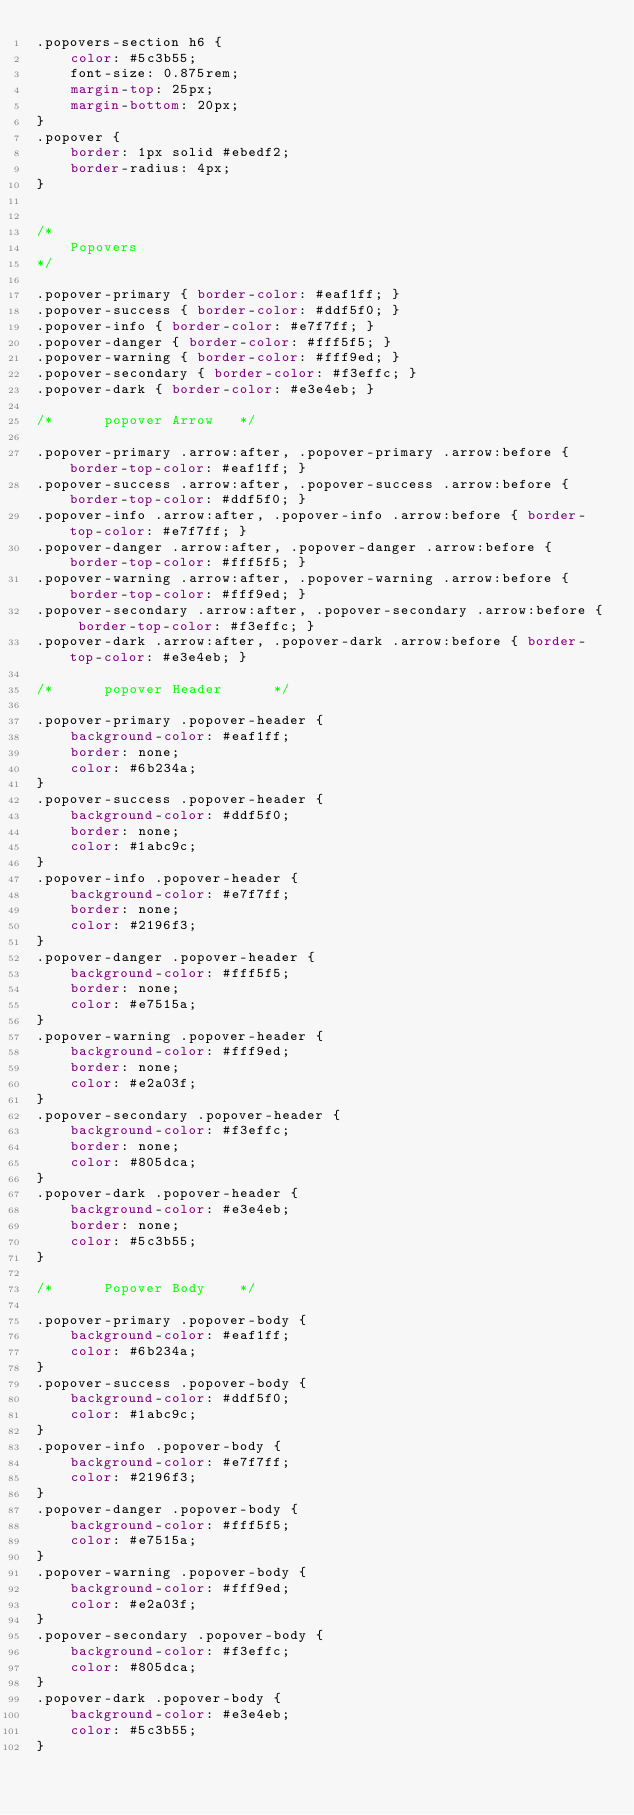Convert code to text. <code><loc_0><loc_0><loc_500><loc_500><_CSS_>.popovers-section h6 {
    color: #5c3b55;
    font-size: 0.875rem;
    margin-top: 25px;
    margin-bottom: 20px;
}
.popover {
    border: 1px solid #ebedf2;
    border-radius: 4px;
}


/*
	Popovers
*/

.popover-primary { border-color: #eaf1ff; }
.popover-success { border-color: #ddf5f0; }
.popover-info { border-color: #e7f7ff; }
.popover-danger { border-color: #fff5f5; }
.popover-warning { border-color: #fff9ed; }
.popover-secondary { border-color: #f3effc; }
.popover-dark { border-color: #e3e4eb; }

/* 		popover Arrow 	*/

.popover-primary .arrow:after, .popover-primary .arrow:before { border-top-color: #eaf1ff; }
.popover-success .arrow:after, .popover-success .arrow:before { border-top-color: #ddf5f0; }
.popover-info .arrow:after, .popover-info .arrow:before { border-top-color: #e7f7ff; }
.popover-danger .arrow:after, .popover-danger .arrow:before { border-top-color: #fff5f5; }
.popover-warning .arrow:after, .popover-warning .arrow:before { border-top-color: #fff9ed; }
.popover-secondary .arrow:after, .popover-secondary .arrow:before { border-top-color: #f3effc; }
.popover-dark .arrow:after, .popover-dark .arrow:before { border-top-color: #e3e4eb; }

/* 		popover Header 		*/

.popover-primary .popover-header {
	background-color: #eaf1ff;
    border: none;
    color: #6b234a;
}
.popover-success .popover-header {
	background-color: #ddf5f0;
    border: none;
    color: #1abc9c;
}
.popover-info .popover-header {
	background-color: #e7f7ff;
    border: none;
    color: #2196f3;
}
.popover-danger .popover-header {
	background-color: #fff5f5;
    border: none;
    color: #e7515a;
}
.popover-warning .popover-header {
	background-color: #fff9ed;
    border: none;
    color: #e2a03f;
}
.popover-secondary .popover-header {
	background-color: #f3effc;
    border: none;
    color: #805dca;
}
.popover-dark .popover-header {
	background-color: #e3e4eb;
    border: none;
    color: #5c3b55;
}

/*  	Popover Body 	*/

.popover-primary .popover-body {
	background-color: #eaf1ff;
    color: #6b234a;
}
.popover-success .popover-body {
	background-color: #ddf5f0;
    color: #1abc9c;
}
.popover-info .popover-body {
	background-color: #e7f7ff;
    color: #2196f3;
}
.popover-danger .popover-body {
	background-color: #fff5f5;
    color: #e7515a;
}
.popover-warning .popover-body {
	background-color: #fff9ed;
    color: #e2a03f;
}
.popover-secondary .popover-body {
	background-color: #f3effc;
    color: #805dca;
}
.popover-dark .popover-body {
	background-color: #e3e4eb;
    color: #5c3b55;
}</code> 